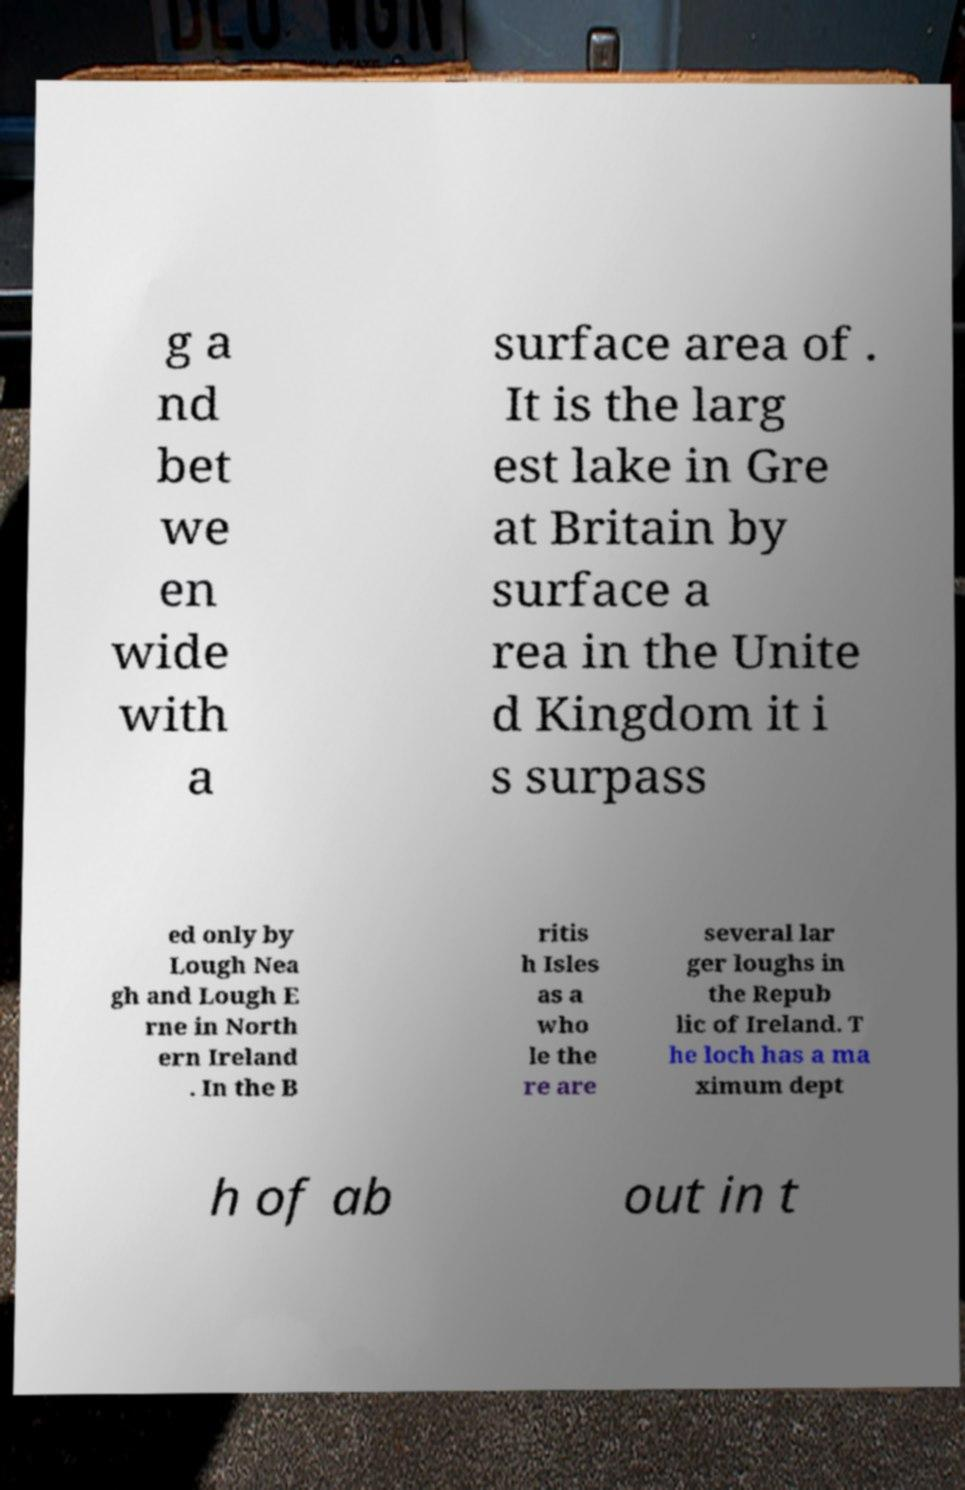Could you assist in decoding the text presented in this image and type it out clearly? g a nd bet we en wide with a surface area of . It is the larg est lake in Gre at Britain by surface a rea in the Unite d Kingdom it i s surpass ed only by Lough Nea gh and Lough E rne in North ern Ireland . In the B ritis h Isles as a who le the re are several lar ger loughs in the Repub lic of Ireland. T he loch has a ma ximum dept h of ab out in t 